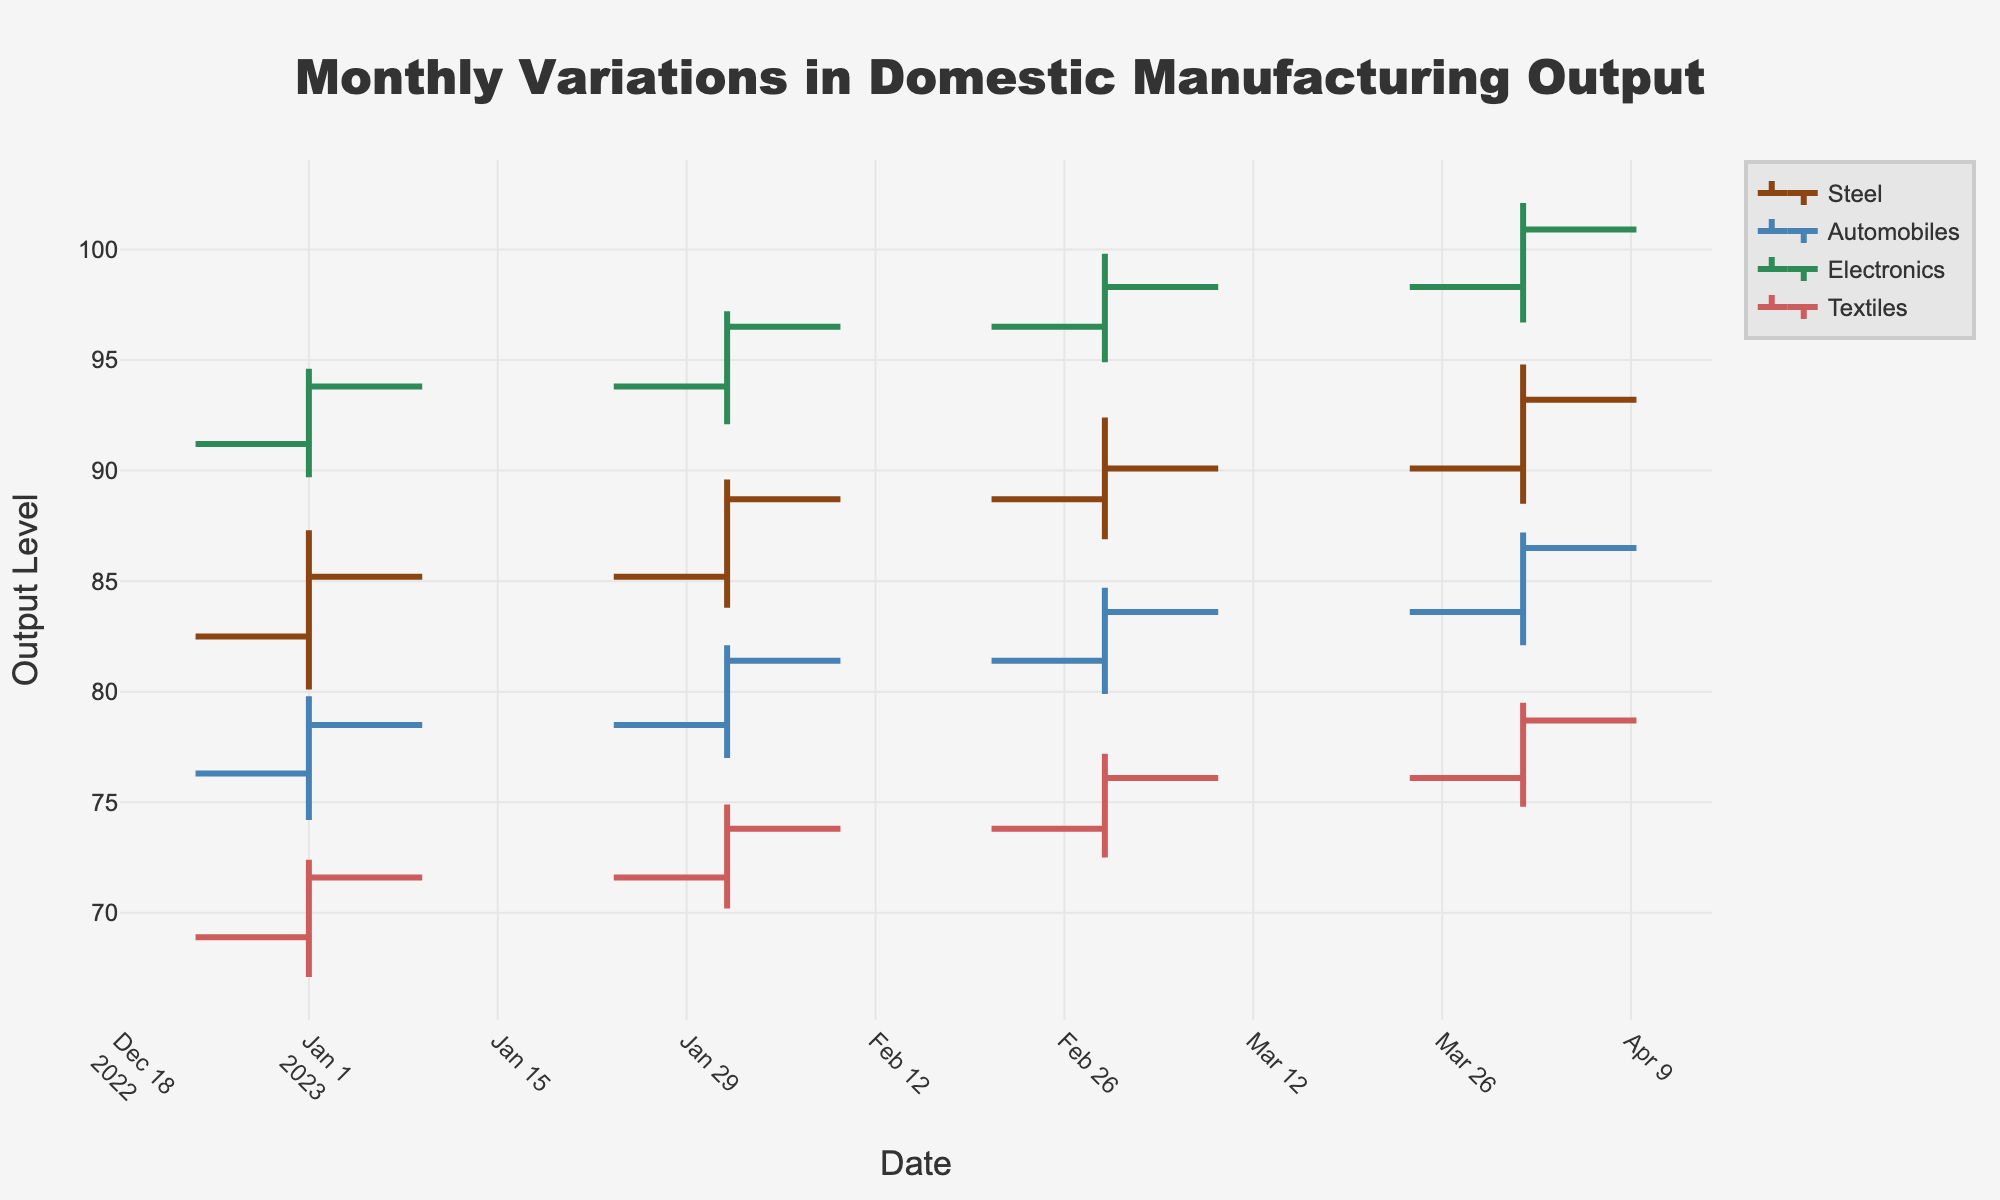What's the title of the chart? The title is displayed at the top center of the chart and reads "Monthly Variations in Domestic Manufacturing Output".
Answer: Monthly Variations in Domestic Manufacturing Output What are the color codes used for each product? Each product has a uniquely assigned color, visible by observing the OHLC chart lines: Steel (brown), Automobiles (blue), Electronics (green), and Textiles (red).
Answer: Steel: brown, Automobiles: blue, Electronics: green, Textiles: red Which month shows the highest closing value for Electronics? Review the OHLC chart for Electronics and note the highest closing value, which is above the closing value for other months. The highest closing value for Electronics is in April.
Answer: April How does the closing value for Textiles change from January to April 2023? Observe the closing values for Textiles in January and April. The closing value in January is 71.6, while in April it is 78.7. The difference is 78.7 - 71.6 = 7.1.
Answer: Increased by 7.1 Which product had the lowest low value in February 2023? Compare the 'Low' values for each product in February 2023 across the chart. Textiles have the lowest low value at 70.2.
Answer: Textiles What is the average closing value for Automobiles over the four months? Calculate the average using the closing values for Automobiles from January to April: (78.5 + 81.4 + 83.6 + 86.5) / 4 = 82.5.
Answer: 82.5 Did Steel have more upward or downward trends over the observed months? For Steel, compare the closing values each month to see how many times they increased or decreased. Steel's closing value increased each month from January to April, indicating more upward trends.
Answer: Upward trends What's the trend of Electronics' output level over the four months? Electronics' closing values show an increasing pattern from January to April, moving from 93.8 to 100.9, consistently rising each month.
Answer: Increasing trend 